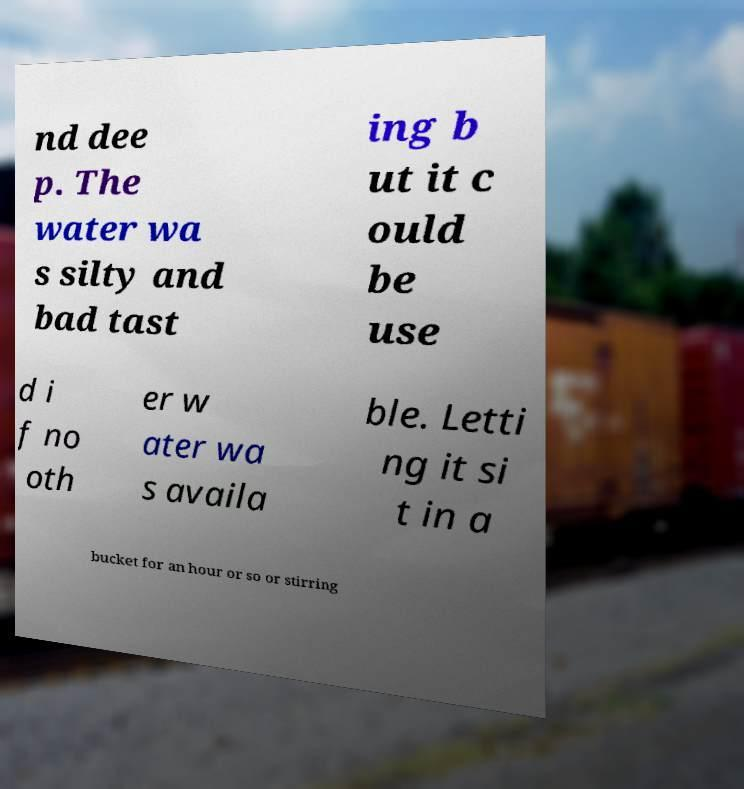For documentation purposes, I need the text within this image transcribed. Could you provide that? nd dee p. The water wa s silty and bad tast ing b ut it c ould be use d i f no oth er w ater wa s availa ble. Letti ng it si t in a bucket for an hour or so or stirring 